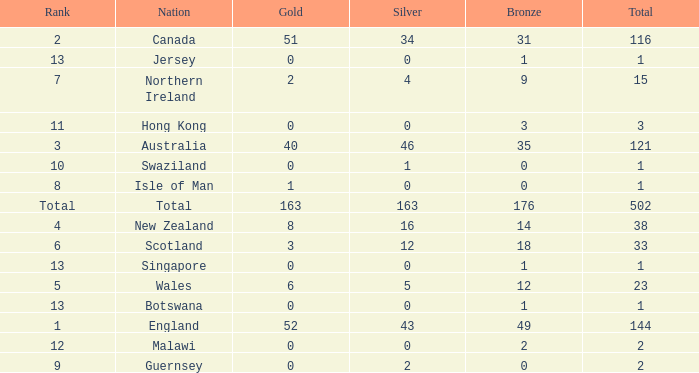Name the average bronze for total less than 1 None. 